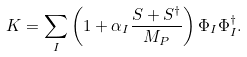Convert formula to latex. <formula><loc_0><loc_0><loc_500><loc_500>K = \sum _ { I } \left ( 1 + \alpha _ { I } \frac { S + S ^ { \dagger } } { M _ { P } } \right ) \Phi _ { I } \Phi _ { I } ^ { \dagger } .</formula> 